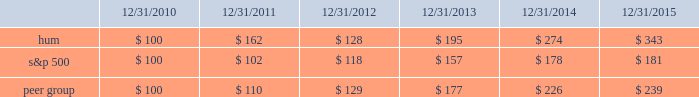Declaration and payment of future quarterly dividends is at the discretion of our board and may be adjusted as business needs or market conditions change .
In addition , under the terms of the merger agreement , we have agreed with aetna to coordinate the declaration and payment of dividends so that our stockholders do not fail to receive a quarterly dividend around the time of the closing of the merger .
On october 29 , 2015 , the board declared a cash dividend of $ 0.29 per share that was paid on january 29 , 2016 to stockholders of record on december 30 , 2015 , for an aggregate amount of $ 43 million .
Stock total return performance the following graph compares our total return to stockholders with the returns of the standard & poor 2019s composite 500 index ( 201cs&p 500 201d ) and the dow jones us select health care providers index ( 201cpeer group 201d ) for the five years ended december 31 , 2015 .
The graph assumes an investment of $ 100 in each of our common stock , the s&p 500 , and the peer group on december 31 , 2010 , and that dividends were reinvested when paid. .
The stock price performance included in this graph is not necessarily indicative of future stock price performance. .
What is the highest return for the first year of the investment? 
Rationale: it is the highest value of the investment , then turned into a percentage to represent the return .
Computations: (162 - 100)
Answer: 62.0. 